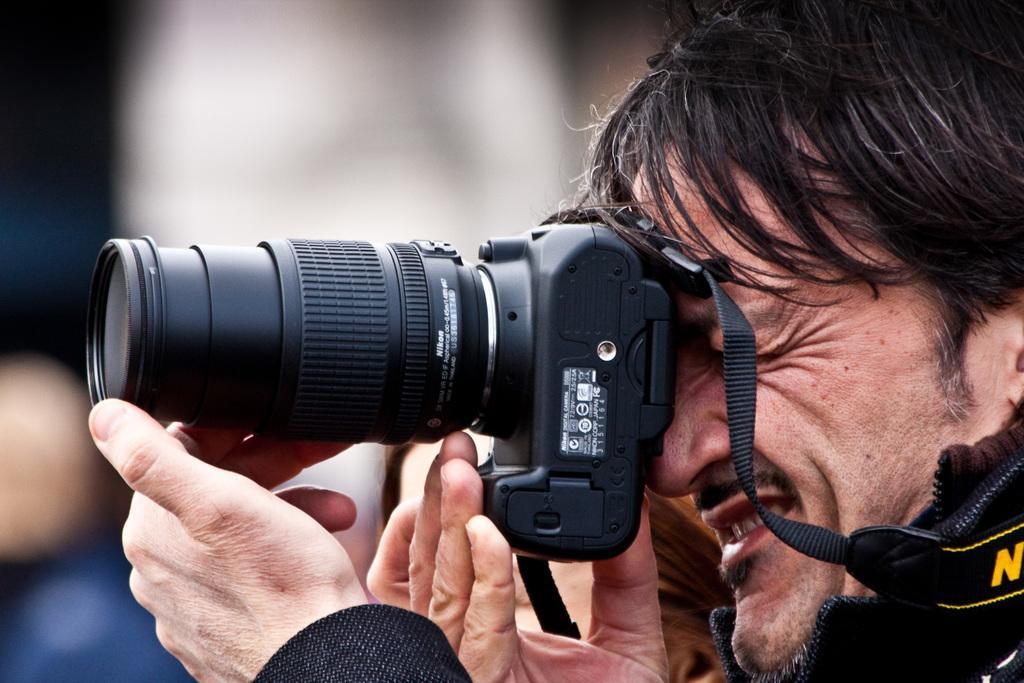Could you give a brief overview of what you see in this image? in this picture there is a man holding a camera. In the background of the image it is blurry. 